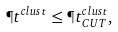Convert formula to latex. <formula><loc_0><loc_0><loc_500><loc_500>\P t ^ { c l u s t } \leq \P t ^ { c l u s t } _ { C U T } ,</formula> 